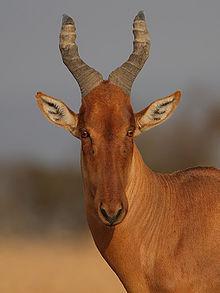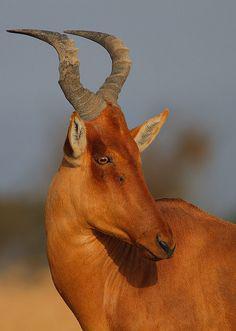The first image is the image on the left, the second image is the image on the right. Considering the images on both sides, is "There is exactly one animal in the image on the right." valid? Answer yes or no. Yes. 